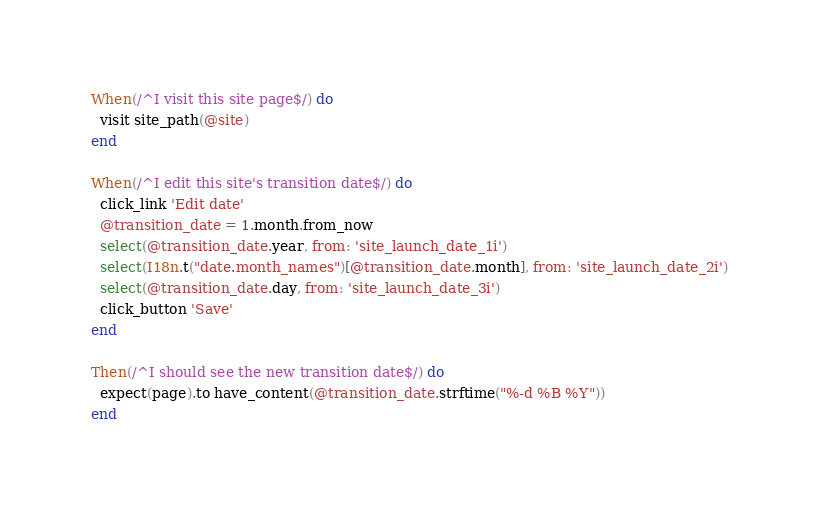<code> <loc_0><loc_0><loc_500><loc_500><_Ruby_>When(/^I visit this site page$/) do
  visit site_path(@site)
end

When(/^I edit this site's transition date$/) do
  click_link 'Edit date'
  @transition_date = 1.month.from_now
  select(@transition_date.year, from: 'site_launch_date_1i')
  select(I18n.t("date.month_names")[@transition_date.month], from: 'site_launch_date_2i')
  select(@transition_date.day, from: 'site_launch_date_3i')
  click_button 'Save'
end

Then(/^I should see the new transition date$/) do
  expect(page).to have_content(@transition_date.strftime("%-d %B %Y"))
end
</code> 